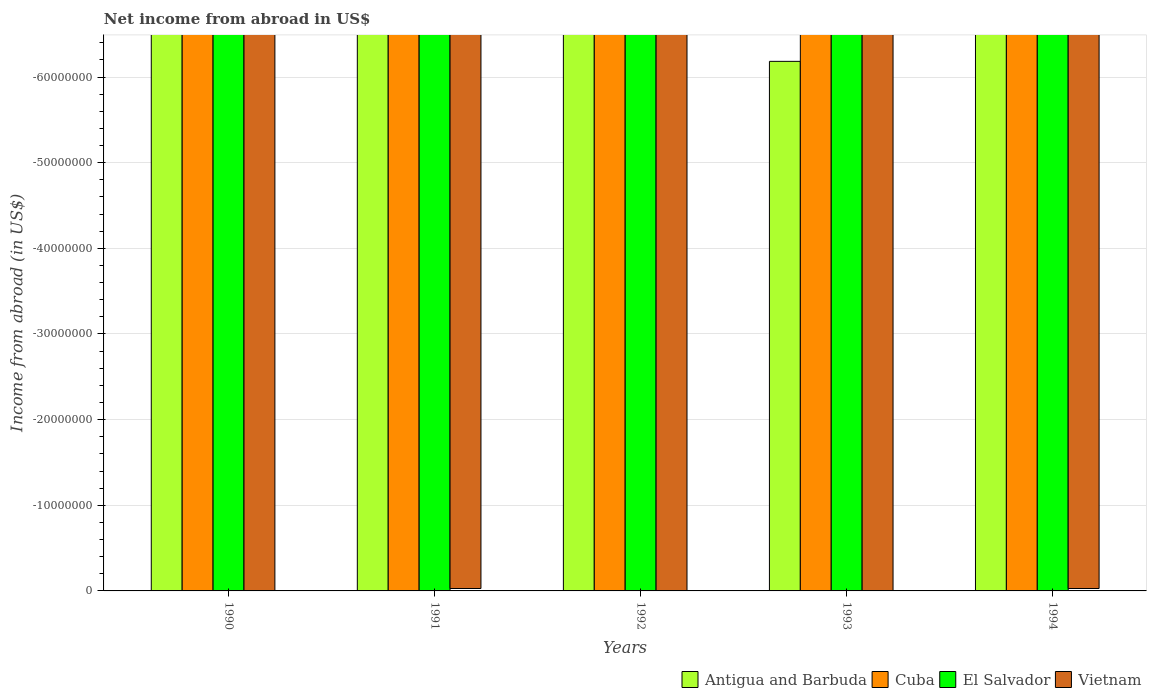Are the number of bars on each tick of the X-axis equal?
Offer a terse response. Yes. How many bars are there on the 5th tick from the right?
Give a very brief answer. 0. In how many cases, is the number of bars for a given year not equal to the number of legend labels?
Make the answer very short. 5. What is the net income from abroad in Vietnam in 1992?
Your answer should be very brief. 0. Across all years, what is the minimum net income from abroad in El Salvador?
Provide a succinct answer. 0. In how many years, is the net income from abroad in Vietnam greater than -60000000 US$?
Make the answer very short. 0. In how many years, is the net income from abroad in Vietnam greater than the average net income from abroad in Vietnam taken over all years?
Your answer should be very brief. 0. How many bars are there?
Offer a very short reply. 0. How many years are there in the graph?
Make the answer very short. 5. Does the graph contain grids?
Your answer should be very brief. Yes. How are the legend labels stacked?
Make the answer very short. Horizontal. What is the title of the graph?
Ensure brevity in your answer.  Net income from abroad in US$. What is the label or title of the Y-axis?
Make the answer very short. Income from abroad (in US$). What is the Income from abroad (in US$) of Cuba in 1991?
Your response must be concise. 0. What is the Income from abroad (in US$) in Antigua and Barbuda in 1992?
Offer a terse response. 0. What is the Income from abroad (in US$) of Cuba in 1992?
Offer a terse response. 0. What is the Income from abroad (in US$) in Antigua and Barbuda in 1993?
Offer a very short reply. 0. What is the Income from abroad (in US$) of Antigua and Barbuda in 1994?
Your answer should be compact. 0. What is the Income from abroad (in US$) of El Salvador in 1994?
Give a very brief answer. 0. What is the Income from abroad (in US$) of Vietnam in 1994?
Give a very brief answer. 0. What is the total Income from abroad (in US$) in Antigua and Barbuda in the graph?
Provide a short and direct response. 0. What is the total Income from abroad (in US$) of Cuba in the graph?
Offer a very short reply. 0. What is the total Income from abroad (in US$) in El Salvador in the graph?
Your answer should be very brief. 0. What is the total Income from abroad (in US$) in Vietnam in the graph?
Your answer should be very brief. 0. What is the average Income from abroad (in US$) in Antigua and Barbuda per year?
Your response must be concise. 0. What is the average Income from abroad (in US$) of El Salvador per year?
Provide a succinct answer. 0. What is the average Income from abroad (in US$) in Vietnam per year?
Keep it short and to the point. 0. 